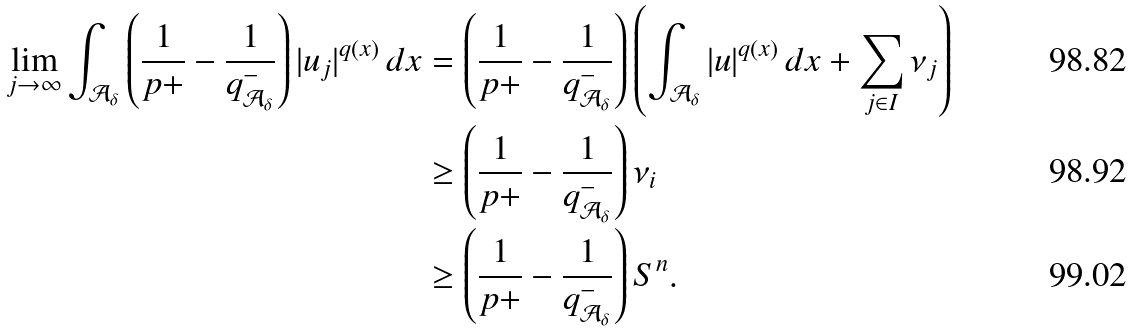<formula> <loc_0><loc_0><loc_500><loc_500>\lim _ { j \to \infty } \int _ { \mathcal { A } _ { \delta } } \left ( \frac { 1 } { p + } - \frac { 1 } { q ^ { - } _ { \mathcal { A } _ { \delta } } } \right ) | u _ { j } | ^ { q ( x ) } \, d x & = \left ( \frac { 1 } { p + } - \frac { 1 } { q ^ { - } _ { \mathcal { A } _ { \delta } } } \right ) \left ( \int _ { \mathcal { A } _ { \delta } } | u | ^ { q ( x ) } \, d x + \sum _ { j \in I } \nu _ { j } \right ) \\ & \geq \left ( \frac { 1 } { p + } - \frac { 1 } { q ^ { - } _ { \mathcal { A } _ { \delta } } } \right ) \nu _ { i } \\ & \geq \left ( \frac { 1 } { p + } - \frac { 1 } { q ^ { - } _ { \mathcal { A } _ { \delta } } } \right ) S ^ { n } .</formula> 